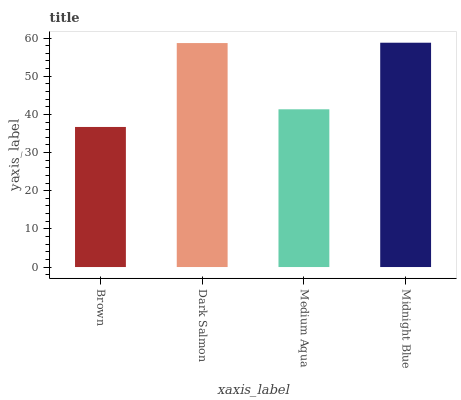Is Brown the minimum?
Answer yes or no. Yes. Is Midnight Blue the maximum?
Answer yes or no. Yes. Is Dark Salmon the minimum?
Answer yes or no. No. Is Dark Salmon the maximum?
Answer yes or no. No. Is Dark Salmon greater than Brown?
Answer yes or no. Yes. Is Brown less than Dark Salmon?
Answer yes or no. Yes. Is Brown greater than Dark Salmon?
Answer yes or no. No. Is Dark Salmon less than Brown?
Answer yes or no. No. Is Dark Salmon the high median?
Answer yes or no. Yes. Is Medium Aqua the low median?
Answer yes or no. Yes. Is Midnight Blue the high median?
Answer yes or no. No. Is Brown the low median?
Answer yes or no. No. 